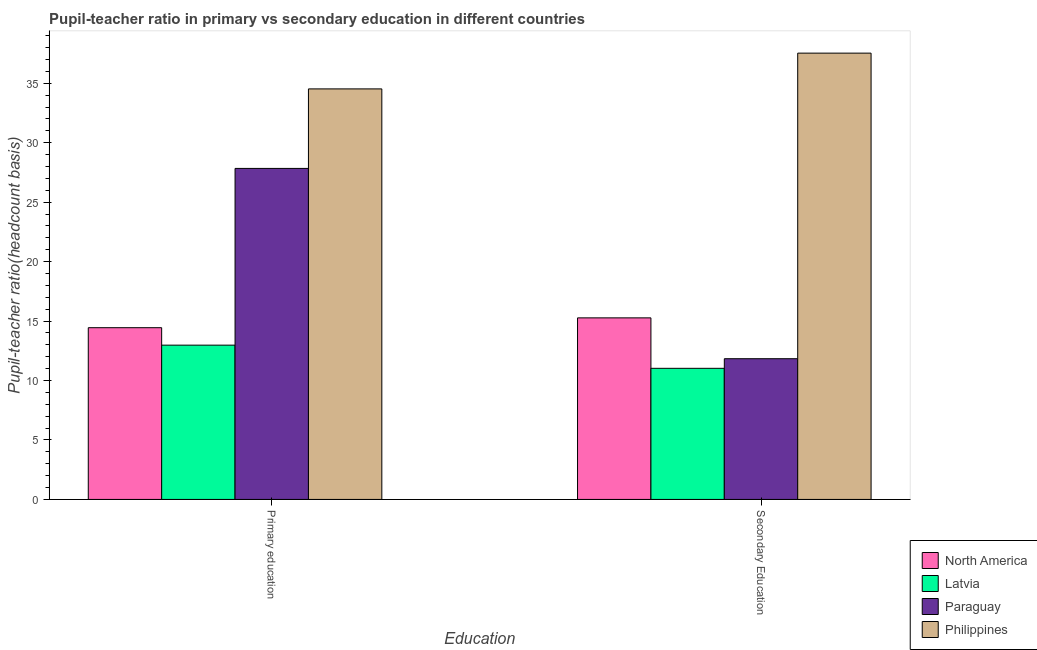How many different coloured bars are there?
Give a very brief answer. 4. Are the number of bars per tick equal to the number of legend labels?
Make the answer very short. Yes. Are the number of bars on each tick of the X-axis equal?
Keep it short and to the point. Yes. How many bars are there on the 1st tick from the left?
Your response must be concise. 4. What is the label of the 1st group of bars from the left?
Your answer should be compact. Primary education. What is the pupil teacher ratio on secondary education in Philippines?
Your answer should be compact. 37.54. Across all countries, what is the maximum pupil-teacher ratio in primary education?
Make the answer very short. 34.53. Across all countries, what is the minimum pupil teacher ratio on secondary education?
Give a very brief answer. 11.03. In which country was the pupil-teacher ratio in primary education minimum?
Offer a terse response. Latvia. What is the total pupil teacher ratio on secondary education in the graph?
Provide a short and direct response. 75.68. What is the difference between the pupil teacher ratio on secondary education in Latvia and that in North America?
Offer a very short reply. -4.24. What is the difference between the pupil teacher ratio on secondary education in Philippines and the pupil-teacher ratio in primary education in Latvia?
Provide a succinct answer. 24.56. What is the average pupil-teacher ratio in primary education per country?
Provide a short and direct response. 22.45. What is the difference between the pupil-teacher ratio in primary education and pupil teacher ratio on secondary education in Philippines?
Offer a terse response. -3.01. What is the ratio of the pupil-teacher ratio in primary education in North America to that in Paraguay?
Your response must be concise. 0.52. What does the 4th bar from the left in Primary education represents?
Provide a short and direct response. Philippines. What does the 3rd bar from the right in Primary education represents?
Your answer should be compact. Latvia. Are all the bars in the graph horizontal?
Offer a very short reply. No. How many countries are there in the graph?
Your answer should be very brief. 4. Does the graph contain grids?
Make the answer very short. No. What is the title of the graph?
Make the answer very short. Pupil-teacher ratio in primary vs secondary education in different countries. Does "Spain" appear as one of the legend labels in the graph?
Keep it short and to the point. No. What is the label or title of the X-axis?
Make the answer very short. Education. What is the label or title of the Y-axis?
Ensure brevity in your answer.  Pupil-teacher ratio(headcount basis). What is the Pupil-teacher ratio(headcount basis) of North America in Primary education?
Keep it short and to the point. 14.45. What is the Pupil-teacher ratio(headcount basis) of Latvia in Primary education?
Your answer should be compact. 12.98. What is the Pupil-teacher ratio(headcount basis) of Paraguay in Primary education?
Offer a very short reply. 27.84. What is the Pupil-teacher ratio(headcount basis) in Philippines in Primary education?
Offer a terse response. 34.53. What is the Pupil-teacher ratio(headcount basis) in North America in Secondary Education?
Keep it short and to the point. 15.27. What is the Pupil-teacher ratio(headcount basis) of Latvia in Secondary Education?
Your answer should be very brief. 11.03. What is the Pupil-teacher ratio(headcount basis) in Paraguay in Secondary Education?
Offer a terse response. 11.84. What is the Pupil-teacher ratio(headcount basis) in Philippines in Secondary Education?
Your answer should be compact. 37.54. Across all Education, what is the maximum Pupil-teacher ratio(headcount basis) of North America?
Your answer should be very brief. 15.27. Across all Education, what is the maximum Pupil-teacher ratio(headcount basis) of Latvia?
Your response must be concise. 12.98. Across all Education, what is the maximum Pupil-teacher ratio(headcount basis) in Paraguay?
Offer a very short reply. 27.84. Across all Education, what is the maximum Pupil-teacher ratio(headcount basis) of Philippines?
Ensure brevity in your answer.  37.54. Across all Education, what is the minimum Pupil-teacher ratio(headcount basis) of North America?
Provide a short and direct response. 14.45. Across all Education, what is the minimum Pupil-teacher ratio(headcount basis) in Latvia?
Provide a succinct answer. 11.03. Across all Education, what is the minimum Pupil-teacher ratio(headcount basis) in Paraguay?
Keep it short and to the point. 11.84. Across all Education, what is the minimum Pupil-teacher ratio(headcount basis) of Philippines?
Provide a succinct answer. 34.53. What is the total Pupil-teacher ratio(headcount basis) of North America in the graph?
Your response must be concise. 29.72. What is the total Pupil-teacher ratio(headcount basis) in Latvia in the graph?
Make the answer very short. 24.01. What is the total Pupil-teacher ratio(headcount basis) of Paraguay in the graph?
Keep it short and to the point. 39.68. What is the total Pupil-teacher ratio(headcount basis) of Philippines in the graph?
Your response must be concise. 72.07. What is the difference between the Pupil-teacher ratio(headcount basis) in North America in Primary education and that in Secondary Education?
Your answer should be compact. -0.83. What is the difference between the Pupil-teacher ratio(headcount basis) of Latvia in Primary education and that in Secondary Education?
Your answer should be very brief. 1.95. What is the difference between the Pupil-teacher ratio(headcount basis) in Paraguay in Primary education and that in Secondary Education?
Provide a succinct answer. 16.01. What is the difference between the Pupil-teacher ratio(headcount basis) of Philippines in Primary education and that in Secondary Education?
Provide a succinct answer. -3.01. What is the difference between the Pupil-teacher ratio(headcount basis) in North America in Primary education and the Pupil-teacher ratio(headcount basis) in Latvia in Secondary Education?
Your answer should be compact. 3.42. What is the difference between the Pupil-teacher ratio(headcount basis) of North America in Primary education and the Pupil-teacher ratio(headcount basis) of Paraguay in Secondary Education?
Provide a succinct answer. 2.61. What is the difference between the Pupil-teacher ratio(headcount basis) in North America in Primary education and the Pupil-teacher ratio(headcount basis) in Philippines in Secondary Education?
Offer a very short reply. -23.09. What is the difference between the Pupil-teacher ratio(headcount basis) in Latvia in Primary education and the Pupil-teacher ratio(headcount basis) in Paraguay in Secondary Education?
Your answer should be compact. 1.14. What is the difference between the Pupil-teacher ratio(headcount basis) of Latvia in Primary education and the Pupil-teacher ratio(headcount basis) of Philippines in Secondary Education?
Give a very brief answer. -24.56. What is the difference between the Pupil-teacher ratio(headcount basis) in Paraguay in Primary education and the Pupil-teacher ratio(headcount basis) in Philippines in Secondary Education?
Provide a succinct answer. -9.7. What is the average Pupil-teacher ratio(headcount basis) of North America per Education?
Provide a short and direct response. 14.86. What is the average Pupil-teacher ratio(headcount basis) in Latvia per Education?
Ensure brevity in your answer.  12. What is the average Pupil-teacher ratio(headcount basis) of Paraguay per Education?
Your answer should be compact. 19.84. What is the average Pupil-teacher ratio(headcount basis) of Philippines per Education?
Offer a terse response. 36.04. What is the difference between the Pupil-teacher ratio(headcount basis) in North America and Pupil-teacher ratio(headcount basis) in Latvia in Primary education?
Offer a terse response. 1.47. What is the difference between the Pupil-teacher ratio(headcount basis) of North America and Pupil-teacher ratio(headcount basis) of Paraguay in Primary education?
Your answer should be compact. -13.4. What is the difference between the Pupil-teacher ratio(headcount basis) in North America and Pupil-teacher ratio(headcount basis) in Philippines in Primary education?
Make the answer very short. -20.09. What is the difference between the Pupil-teacher ratio(headcount basis) of Latvia and Pupil-teacher ratio(headcount basis) of Paraguay in Primary education?
Your answer should be very brief. -14.87. What is the difference between the Pupil-teacher ratio(headcount basis) of Latvia and Pupil-teacher ratio(headcount basis) of Philippines in Primary education?
Provide a succinct answer. -21.55. What is the difference between the Pupil-teacher ratio(headcount basis) of Paraguay and Pupil-teacher ratio(headcount basis) of Philippines in Primary education?
Offer a terse response. -6.69. What is the difference between the Pupil-teacher ratio(headcount basis) of North America and Pupil-teacher ratio(headcount basis) of Latvia in Secondary Education?
Your answer should be compact. 4.24. What is the difference between the Pupil-teacher ratio(headcount basis) in North America and Pupil-teacher ratio(headcount basis) in Paraguay in Secondary Education?
Offer a terse response. 3.44. What is the difference between the Pupil-teacher ratio(headcount basis) in North America and Pupil-teacher ratio(headcount basis) in Philippines in Secondary Education?
Provide a succinct answer. -22.27. What is the difference between the Pupil-teacher ratio(headcount basis) in Latvia and Pupil-teacher ratio(headcount basis) in Paraguay in Secondary Education?
Ensure brevity in your answer.  -0.81. What is the difference between the Pupil-teacher ratio(headcount basis) of Latvia and Pupil-teacher ratio(headcount basis) of Philippines in Secondary Education?
Your response must be concise. -26.51. What is the difference between the Pupil-teacher ratio(headcount basis) in Paraguay and Pupil-teacher ratio(headcount basis) in Philippines in Secondary Education?
Offer a very short reply. -25.7. What is the ratio of the Pupil-teacher ratio(headcount basis) of North America in Primary education to that in Secondary Education?
Your answer should be compact. 0.95. What is the ratio of the Pupil-teacher ratio(headcount basis) of Latvia in Primary education to that in Secondary Education?
Ensure brevity in your answer.  1.18. What is the ratio of the Pupil-teacher ratio(headcount basis) of Paraguay in Primary education to that in Secondary Education?
Give a very brief answer. 2.35. What is the ratio of the Pupil-teacher ratio(headcount basis) of Philippines in Primary education to that in Secondary Education?
Ensure brevity in your answer.  0.92. What is the difference between the highest and the second highest Pupil-teacher ratio(headcount basis) in North America?
Ensure brevity in your answer.  0.83. What is the difference between the highest and the second highest Pupil-teacher ratio(headcount basis) in Latvia?
Your answer should be very brief. 1.95. What is the difference between the highest and the second highest Pupil-teacher ratio(headcount basis) in Paraguay?
Provide a short and direct response. 16.01. What is the difference between the highest and the second highest Pupil-teacher ratio(headcount basis) in Philippines?
Offer a terse response. 3.01. What is the difference between the highest and the lowest Pupil-teacher ratio(headcount basis) of North America?
Provide a succinct answer. 0.83. What is the difference between the highest and the lowest Pupil-teacher ratio(headcount basis) of Latvia?
Your answer should be compact. 1.95. What is the difference between the highest and the lowest Pupil-teacher ratio(headcount basis) in Paraguay?
Give a very brief answer. 16.01. What is the difference between the highest and the lowest Pupil-teacher ratio(headcount basis) of Philippines?
Give a very brief answer. 3.01. 